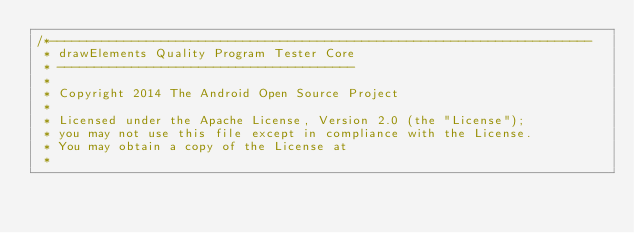Convert code to text. <code><loc_0><loc_0><loc_500><loc_500><_C++_>/*-------------------------------------------------------------------------
 * drawElements Quality Program Tester Core
 * ----------------------------------------
 *
 * Copyright 2014 The Android Open Source Project
 *
 * Licensed under the Apache License, Version 2.0 (the "License");
 * you may not use this file except in compliance with the License.
 * You may obtain a copy of the License at
 *</code> 